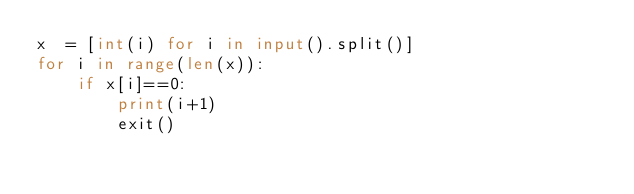Convert code to text. <code><loc_0><loc_0><loc_500><loc_500><_Python_>x  = [int(i) for i in input().split()]
for i in range(len(x)):
    if x[i]==0:
        print(i+1)
        exit()</code> 